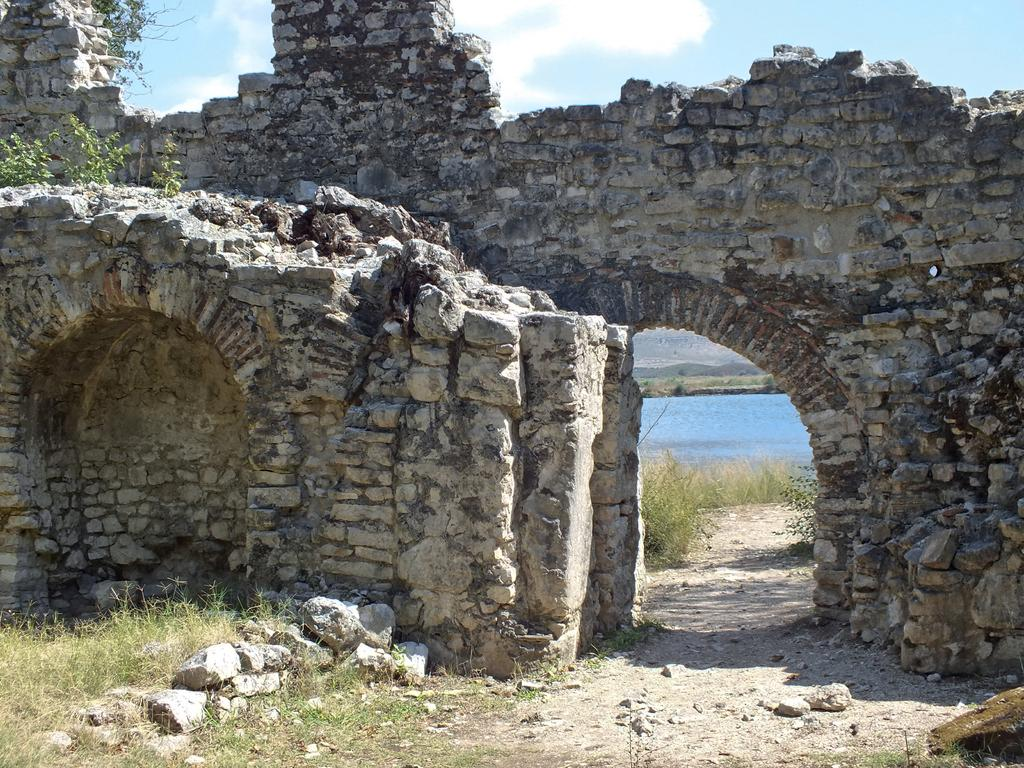What type of structure is present in the image? There is a wall in the image. What natural elements can be seen in the image? There are rocks, grass, and plants visible in the image. What can be seen in the background of the image? Water and the sky are visible in the background of the image. How many geese are flying over the hospital in the image? There is no hospital or geese present in the image. 